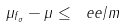<formula> <loc_0><loc_0><loc_500><loc_500>\| \mu _ { f _ { \sigma } } - \mu \| \leq \ e e / m</formula> 